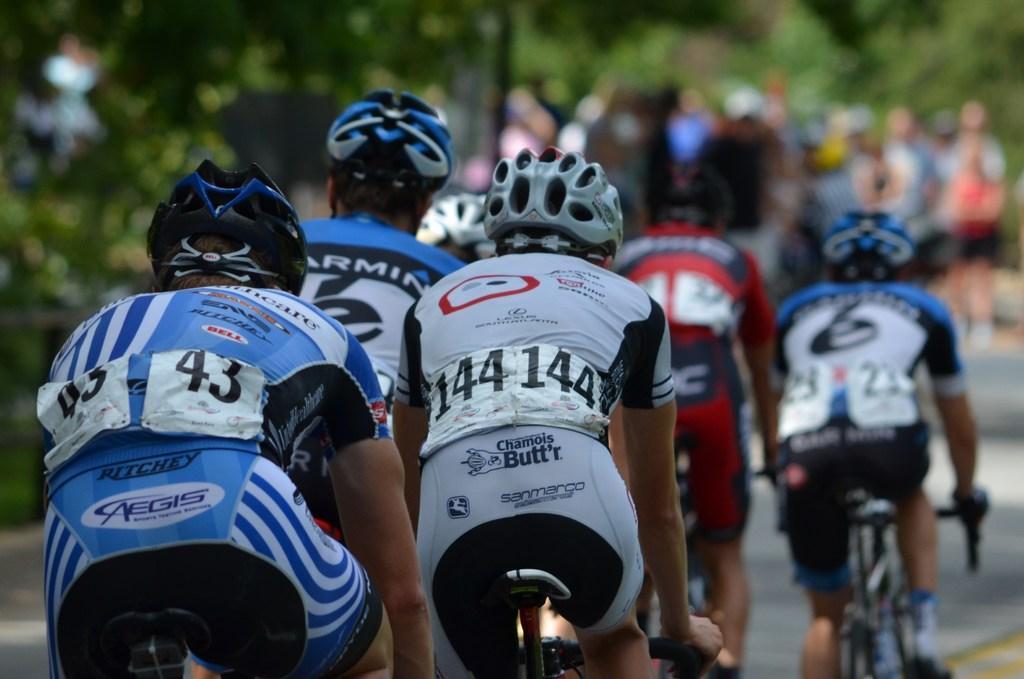Can you describe this image briefly? In this image I can see few persons wearing white, blue and black colored dresses and helmets are riding bicycles. I can see the blurry background in which I can see few trees and few persons. 